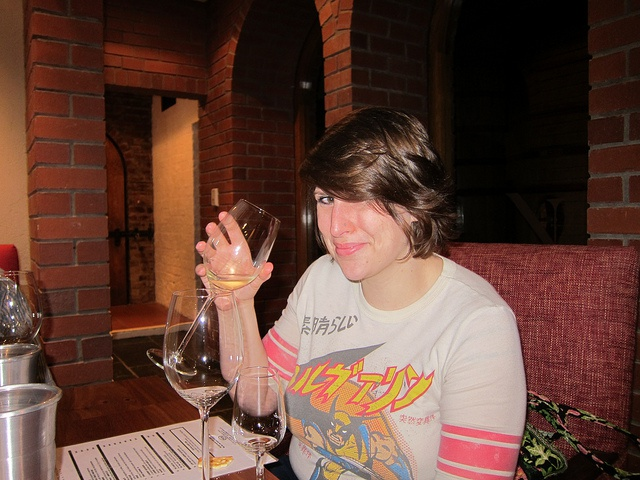Describe the objects in this image and their specific colors. I can see people in maroon, tan, lightgray, and black tones, dining table in maroon, black, tan, and darkgray tones, chair in maroon, black, and brown tones, couch in maroon, black, and brown tones, and handbag in maroon, black, darkgreen, and gray tones in this image. 